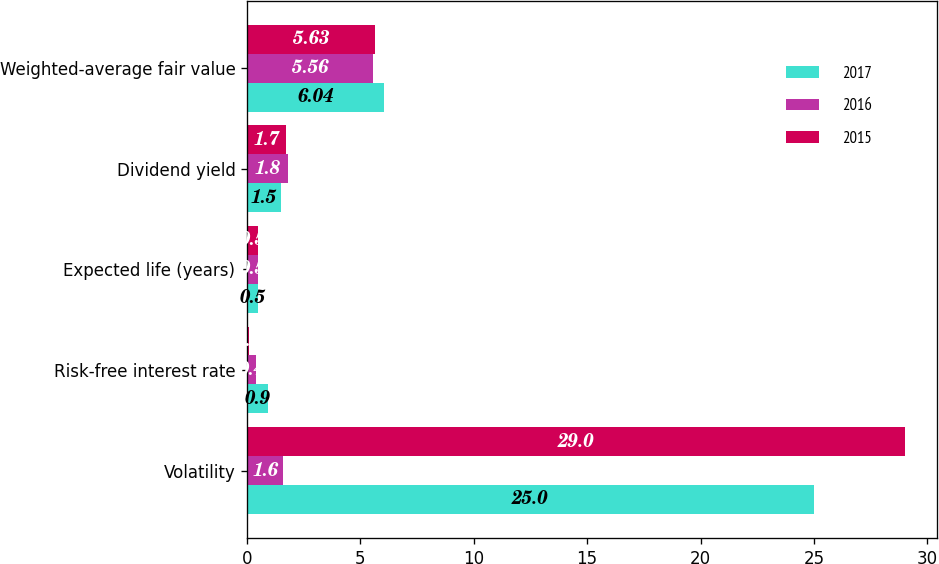Convert chart. <chart><loc_0><loc_0><loc_500><loc_500><stacked_bar_chart><ecel><fcel>Volatility<fcel>Risk-free interest rate<fcel>Expected life (years)<fcel>Dividend yield<fcel>Weighted-average fair value<nl><fcel>2017<fcel>25<fcel>0.9<fcel>0.5<fcel>1.5<fcel>6.04<nl><fcel>2016<fcel>1.6<fcel>0.4<fcel>0.5<fcel>1.8<fcel>5.56<nl><fcel>2015<fcel>29<fcel>0.1<fcel>0.5<fcel>1.7<fcel>5.63<nl></chart> 